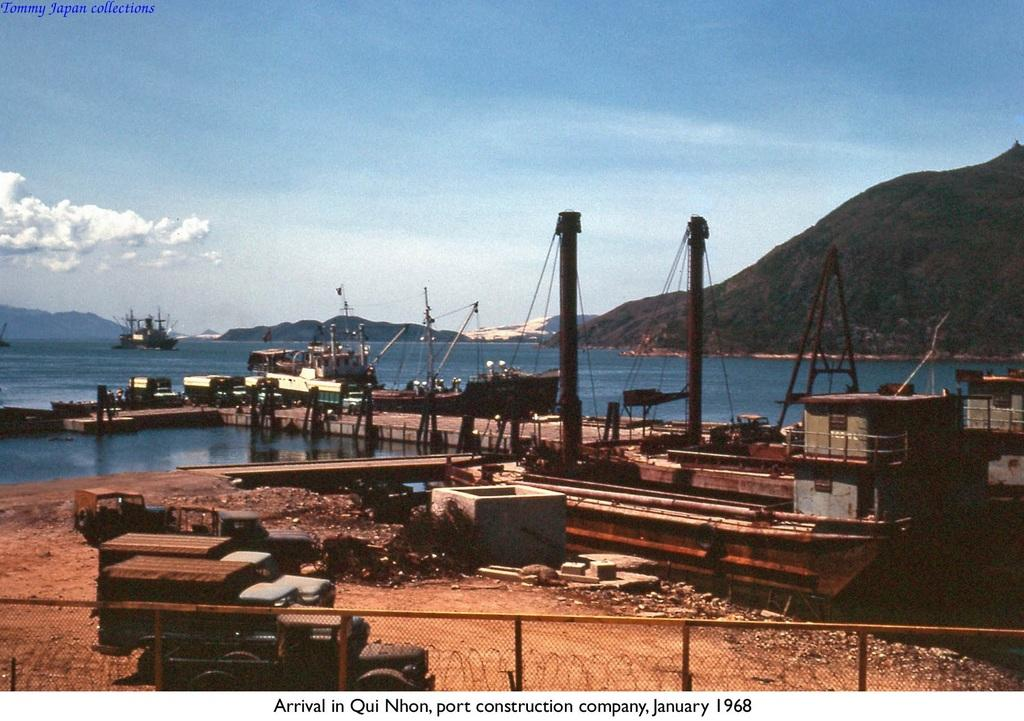What type of barrier can be seen in the image? There is a fence in the image. What types of transportation are present in the image? There are vehicles in the image. Can you describe the object in the image? There is an object in the image, but its specific nature is not clear from the provided facts. What type of terrain is visible in the image? There are stones in the image, which suggests a rocky or stony surface. What is happening above the water in the image? There are boats above the water in the image. What can be seen in the distance in the image? There are hills visible in the background of the image. What type of vegetation is present in the background of the image? There are trees in the background of the image. What part of the natural environment is visible in the background of the image? The sky is visible in the background of the image, and there are clouds in the sky. Is there any text present in the image? Yes, there is some text in the image. What type of coach is present in the image? There is no coach present in the image. Can you describe the leg of the person in the image? There is no person present in the image, so there is no leg to describe. What type of legal advice is being given in the image? There is no lawyer or legal advice present in the image. 